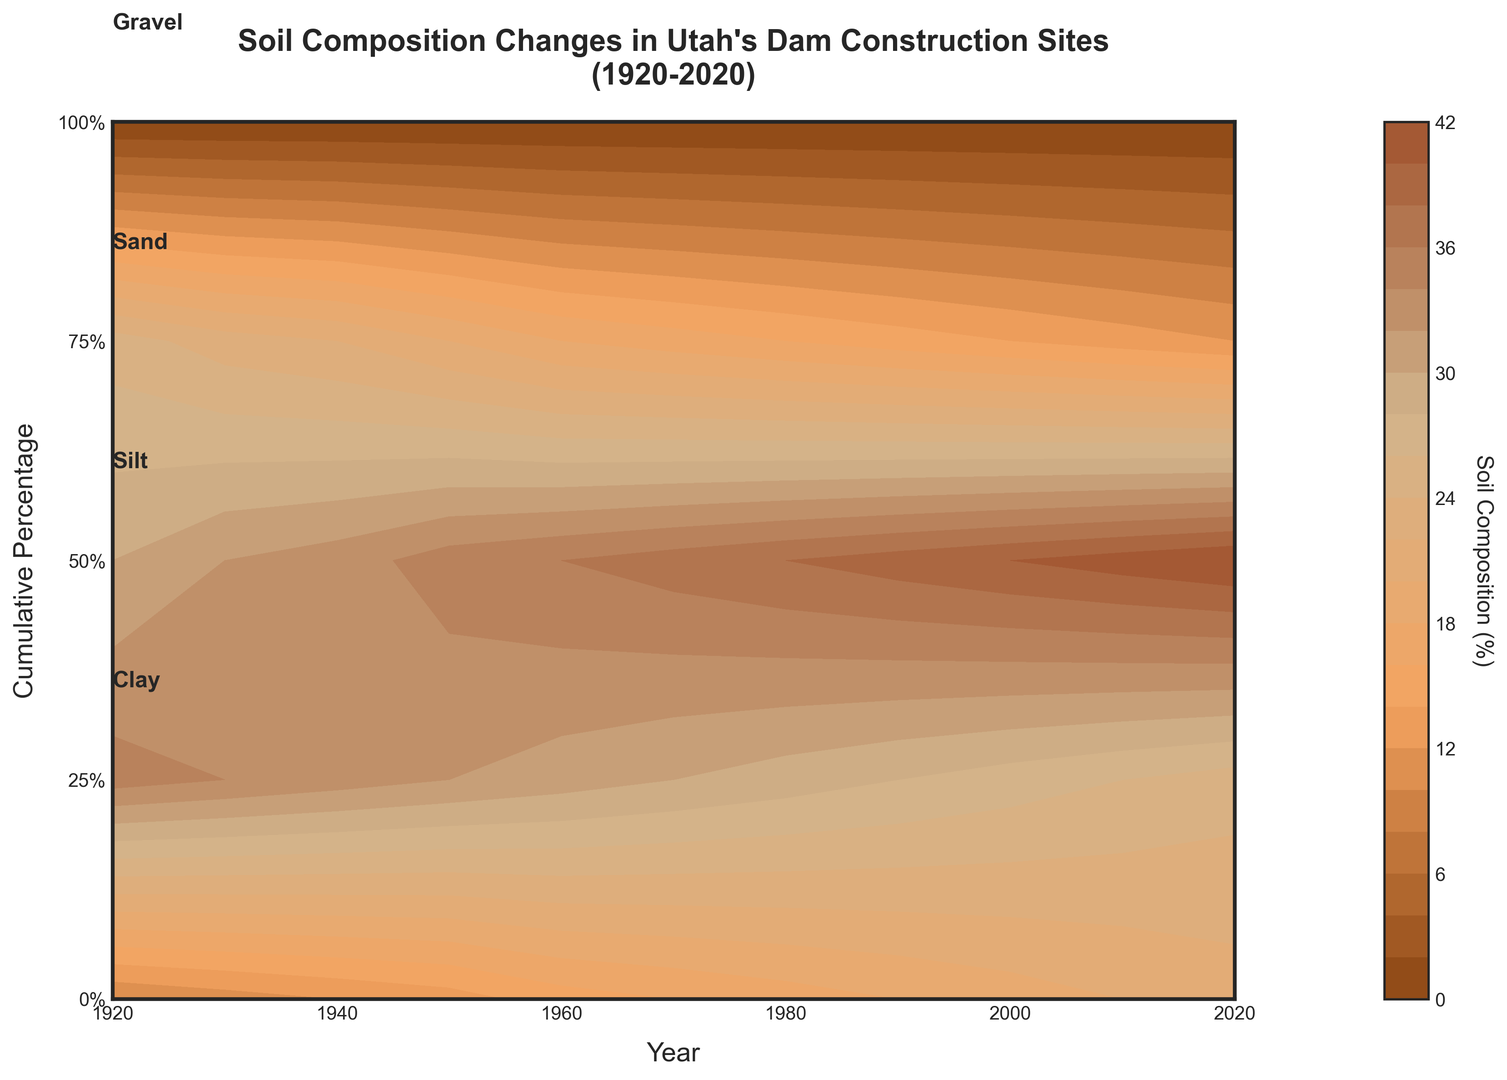What trend do you observe in the Clay% from 1920 to 2020? From 1920 to 2020, the Clay% consistently decreases over time. This can be observed as the contour lines for Clay% move downwards on the graph.
Answer: Decreasing Which soil component consistently increased in percentage from 1920 to 2020? The Gravel% consistently increased from 1920 to 2020, which is evident as the contour lines for Gravel% move upwards on the graph throughout the period.
Answer: Gravel How does the percentage of Sand in 1950 compare to its percentage in 2020? In 1950, the Sand% is roughly 32%, whereas, in 2020, it has decreased to approximately 25%.
Answer: Decreased What is the difference in Silt% between 1940 and 1990? In 1940, the Silt% is around 33%, and in 1990, it is about 39%. The difference is 39% - 33% = 6%.
Answer: 6% Which year has the highest Clay% and what is its approximate value? 1920 has the highest Clay% with an approximate value of 25%. This can be observed as the contour line for Clay% is highest at 1920.
Answer: 1920, 25% How has the Sand% changed from 1920 to 1980? In 1920, Sand% is around 35%, and by 1980, it has reduced to approximately 29%. This shows a decreasing trend over the years.
Answer: Decreased What is the approximate percentage of Gravel in 1970? The contour lines indicate that the Gravel% in 1970 is approximately 16%. This is observed where the curve for Gravel meets the year 1970.
Answer: 16% How does the Silt% in 2000 compare to the Silt% in 1940? In 2000, the Silt% is approximately 40%, while in 1940, it is around 33%. This shows an increase in Silt% over the years.
Answer: Increased What is the cumulative percentage of Soil compositions at 1960 around the 50% cumulative percentage line? The cumulative percentage of Soil compositions in 1960 around the 50% line should be interpreted in layers, including Gravel, Sand, and Silt. Gravel around 15%, Sand around 31%, and Silt around 36%, summing to 15% + 31% + 36% = 82%.
Answer: 82% What year has the lowest Sand% and what is its value? 2020 has the lowest Sand% with its value being around 25%. This is observed as the lowest contour line for Sand% at the latest year on the graph.
Answer: 2020, 25% 